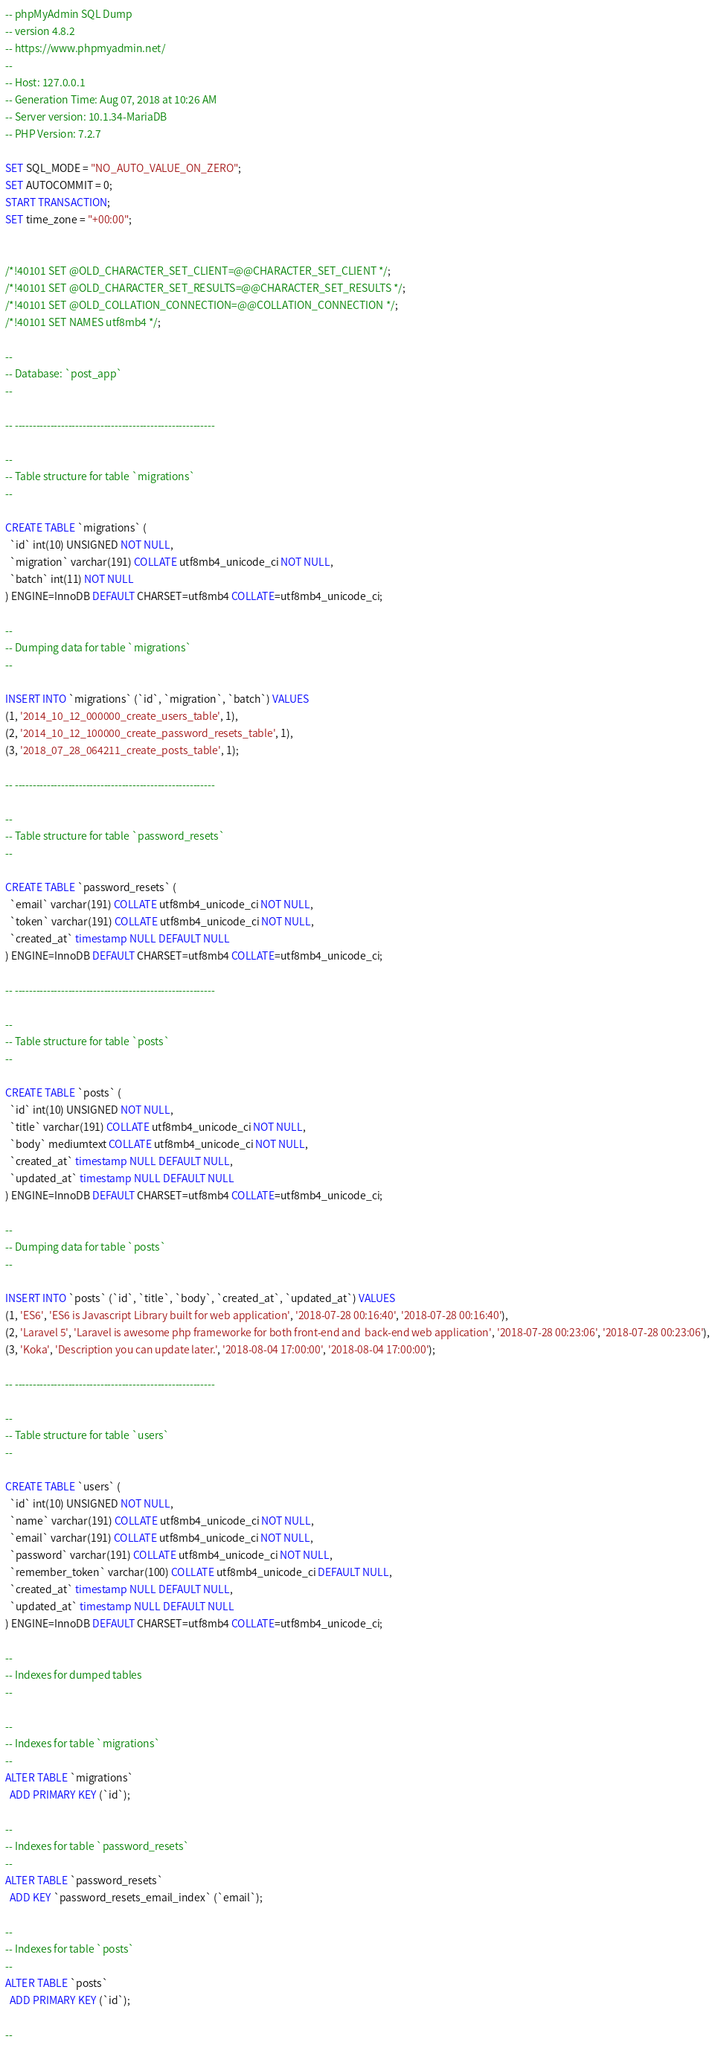Convert code to text. <code><loc_0><loc_0><loc_500><loc_500><_SQL_>-- phpMyAdmin SQL Dump
-- version 4.8.2
-- https://www.phpmyadmin.net/
--
-- Host: 127.0.0.1
-- Generation Time: Aug 07, 2018 at 10:26 AM
-- Server version: 10.1.34-MariaDB
-- PHP Version: 7.2.7

SET SQL_MODE = "NO_AUTO_VALUE_ON_ZERO";
SET AUTOCOMMIT = 0;
START TRANSACTION;
SET time_zone = "+00:00";


/*!40101 SET @OLD_CHARACTER_SET_CLIENT=@@CHARACTER_SET_CLIENT */;
/*!40101 SET @OLD_CHARACTER_SET_RESULTS=@@CHARACTER_SET_RESULTS */;
/*!40101 SET @OLD_COLLATION_CONNECTION=@@COLLATION_CONNECTION */;
/*!40101 SET NAMES utf8mb4 */;

--
-- Database: `post_app`
--

-- --------------------------------------------------------

--
-- Table structure for table `migrations`
--

CREATE TABLE `migrations` (
  `id` int(10) UNSIGNED NOT NULL,
  `migration` varchar(191) COLLATE utf8mb4_unicode_ci NOT NULL,
  `batch` int(11) NOT NULL
) ENGINE=InnoDB DEFAULT CHARSET=utf8mb4 COLLATE=utf8mb4_unicode_ci;

--
-- Dumping data for table `migrations`
--

INSERT INTO `migrations` (`id`, `migration`, `batch`) VALUES
(1, '2014_10_12_000000_create_users_table', 1),
(2, '2014_10_12_100000_create_password_resets_table', 1),
(3, '2018_07_28_064211_create_posts_table', 1);

-- --------------------------------------------------------

--
-- Table structure for table `password_resets`
--

CREATE TABLE `password_resets` (
  `email` varchar(191) COLLATE utf8mb4_unicode_ci NOT NULL,
  `token` varchar(191) COLLATE utf8mb4_unicode_ci NOT NULL,
  `created_at` timestamp NULL DEFAULT NULL
) ENGINE=InnoDB DEFAULT CHARSET=utf8mb4 COLLATE=utf8mb4_unicode_ci;

-- --------------------------------------------------------

--
-- Table structure for table `posts`
--

CREATE TABLE `posts` (
  `id` int(10) UNSIGNED NOT NULL,
  `title` varchar(191) COLLATE utf8mb4_unicode_ci NOT NULL,
  `body` mediumtext COLLATE utf8mb4_unicode_ci NOT NULL,
  `created_at` timestamp NULL DEFAULT NULL,
  `updated_at` timestamp NULL DEFAULT NULL
) ENGINE=InnoDB DEFAULT CHARSET=utf8mb4 COLLATE=utf8mb4_unicode_ci;

--
-- Dumping data for table `posts`
--

INSERT INTO `posts` (`id`, `title`, `body`, `created_at`, `updated_at`) VALUES
(1, 'ES6', 'ES6 is Javascript Library built for web application', '2018-07-28 00:16:40', '2018-07-28 00:16:40'),
(2, 'Laravel 5', 'Laravel is awesome php frameworke for both front-end and  back-end web application', '2018-07-28 00:23:06', '2018-07-28 00:23:06'),
(3, 'Koka', 'Description you can update later.', '2018-08-04 17:00:00', '2018-08-04 17:00:00');

-- --------------------------------------------------------

--
-- Table structure for table `users`
--

CREATE TABLE `users` (
  `id` int(10) UNSIGNED NOT NULL,
  `name` varchar(191) COLLATE utf8mb4_unicode_ci NOT NULL,
  `email` varchar(191) COLLATE utf8mb4_unicode_ci NOT NULL,
  `password` varchar(191) COLLATE utf8mb4_unicode_ci NOT NULL,
  `remember_token` varchar(100) COLLATE utf8mb4_unicode_ci DEFAULT NULL,
  `created_at` timestamp NULL DEFAULT NULL,
  `updated_at` timestamp NULL DEFAULT NULL
) ENGINE=InnoDB DEFAULT CHARSET=utf8mb4 COLLATE=utf8mb4_unicode_ci;

--
-- Indexes for dumped tables
--

--
-- Indexes for table `migrations`
--
ALTER TABLE `migrations`
  ADD PRIMARY KEY (`id`);

--
-- Indexes for table `password_resets`
--
ALTER TABLE `password_resets`
  ADD KEY `password_resets_email_index` (`email`);

--
-- Indexes for table `posts`
--
ALTER TABLE `posts`
  ADD PRIMARY KEY (`id`);

--</code> 